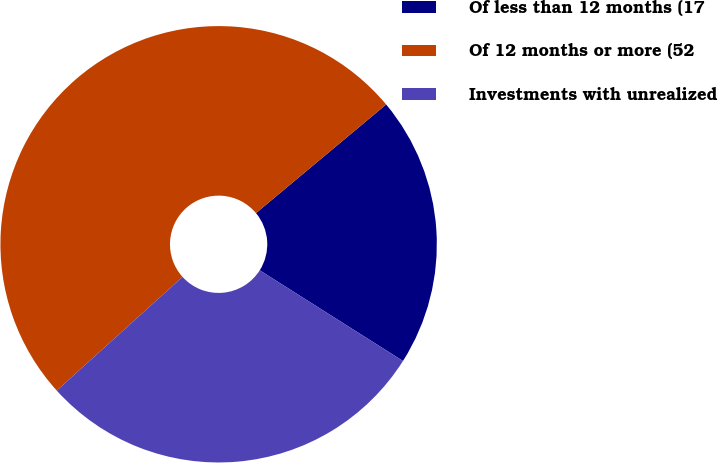<chart> <loc_0><loc_0><loc_500><loc_500><pie_chart><fcel>Of less than 12 months (17<fcel>Of 12 months or more (52<fcel>Investments with unrealized<nl><fcel>20.05%<fcel>50.63%<fcel>29.32%<nl></chart> 